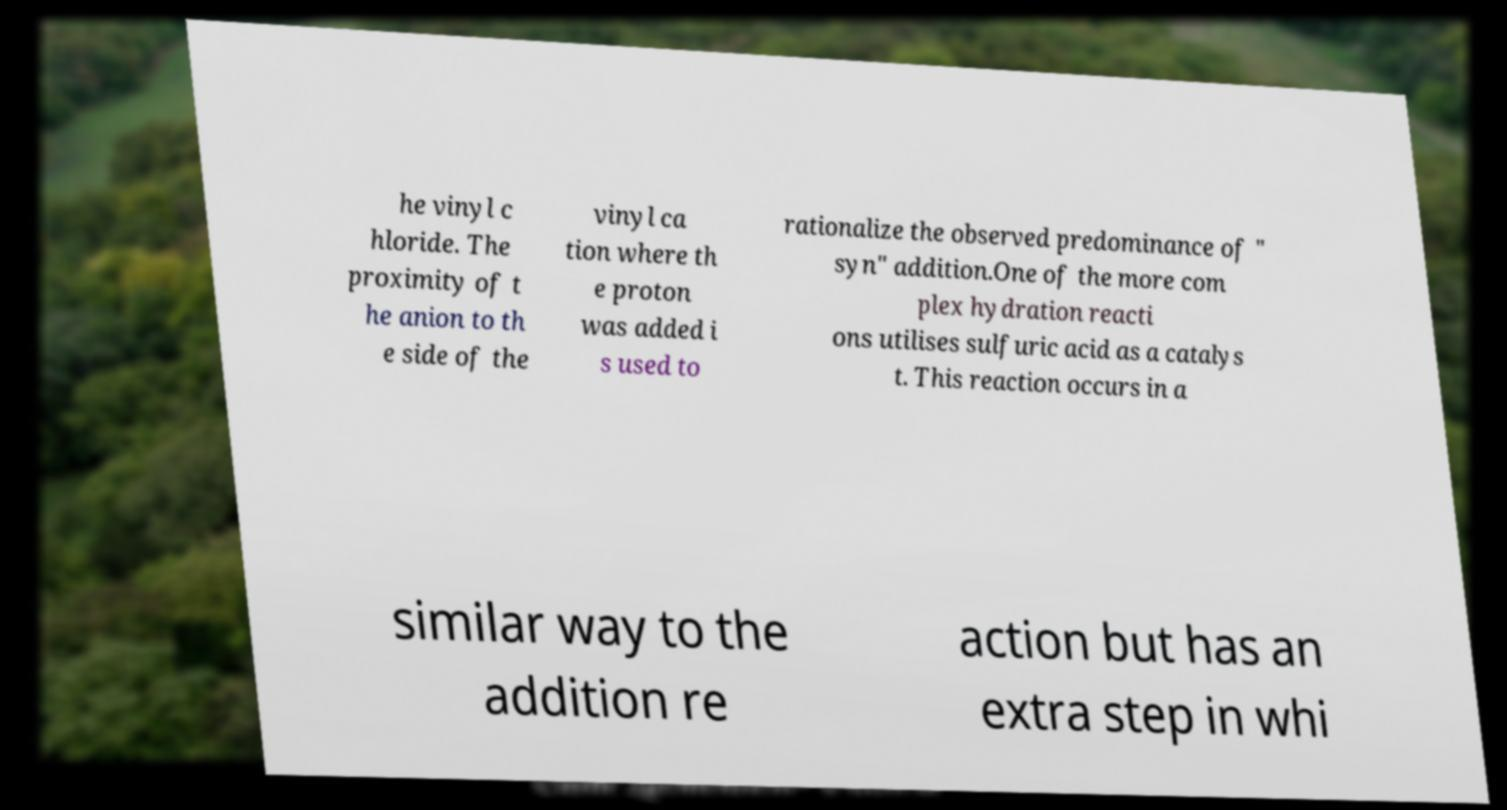For documentation purposes, I need the text within this image transcribed. Could you provide that? he vinyl c hloride. The proximity of t he anion to th e side of the vinyl ca tion where th e proton was added i s used to rationalize the observed predominance of " syn" addition.One of the more com plex hydration reacti ons utilises sulfuric acid as a catalys t. This reaction occurs in a similar way to the addition re action but has an extra step in whi 